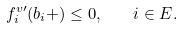Convert formula to latex. <formula><loc_0><loc_0><loc_500><loc_500>f ^ { v \prime } _ { i } ( b _ { i } + ) \leq 0 , \quad i \in E .</formula> 